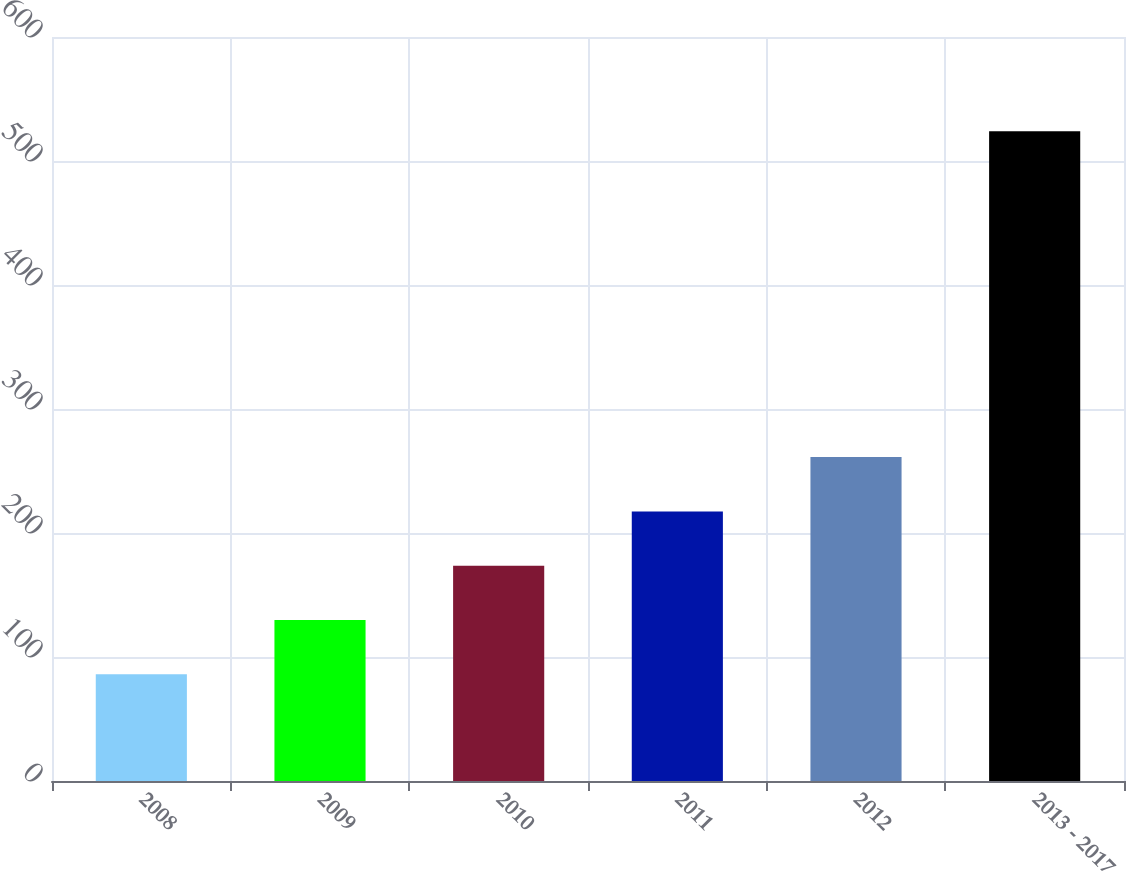Convert chart to OTSL. <chart><loc_0><loc_0><loc_500><loc_500><bar_chart><fcel>2008<fcel>2009<fcel>2010<fcel>2011<fcel>2012<fcel>2013 - 2017<nl><fcel>86<fcel>129.8<fcel>173.6<fcel>217.4<fcel>261.2<fcel>524<nl></chart> 